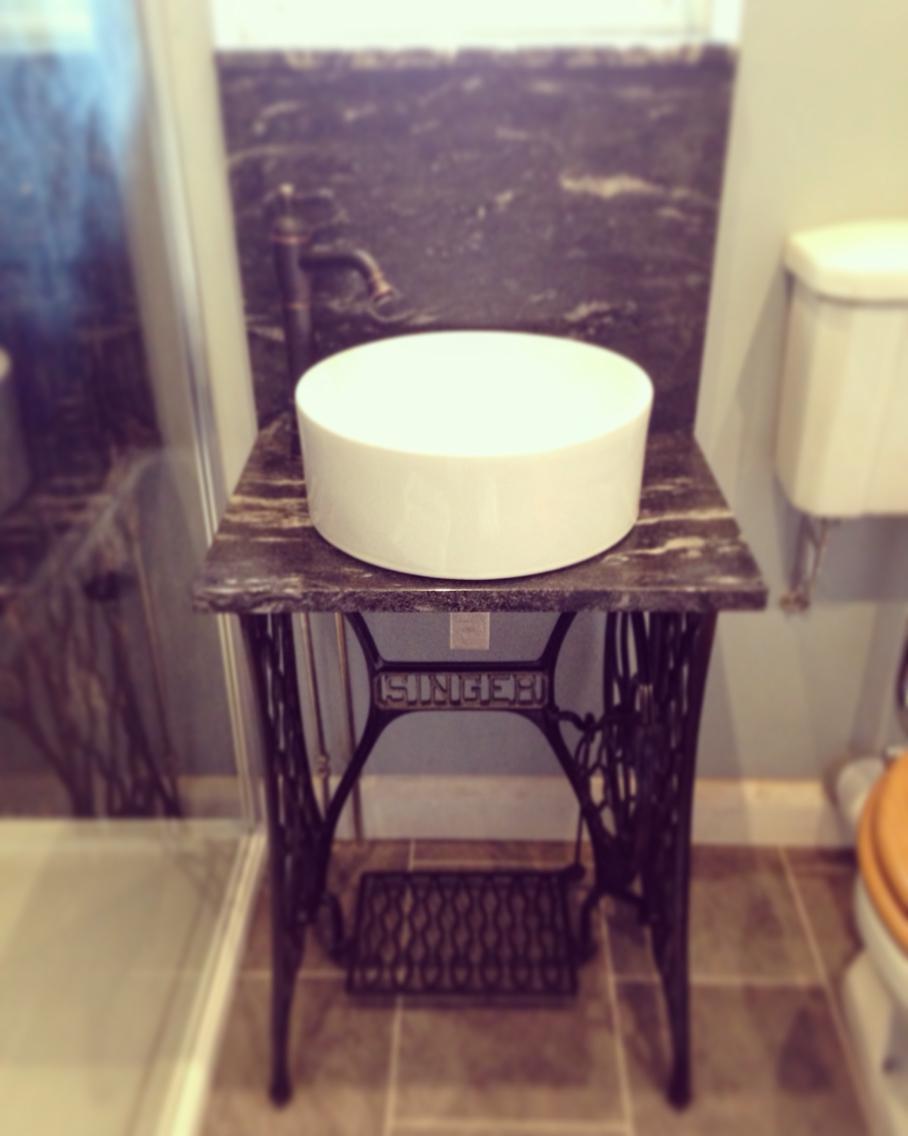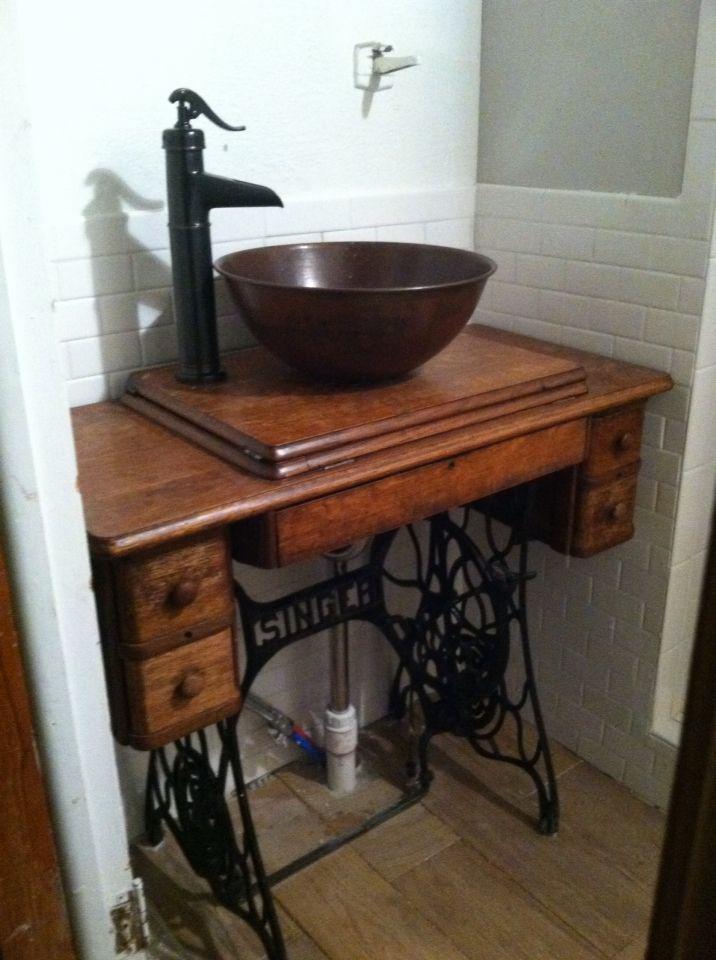The first image is the image on the left, the second image is the image on the right. Considering the images on both sides, is "Each image shows a dark metal sewing machine base used as part of a sink vanity, and at least one image features a wood grain counter that holds the sink." valid? Answer yes or no. Yes. The first image is the image on the left, the second image is the image on the right. Analyze the images presented: Is the assertion "Both images show a sewing table with a black metal base converted into a bathroom sink." valid? Answer yes or no. Yes. 